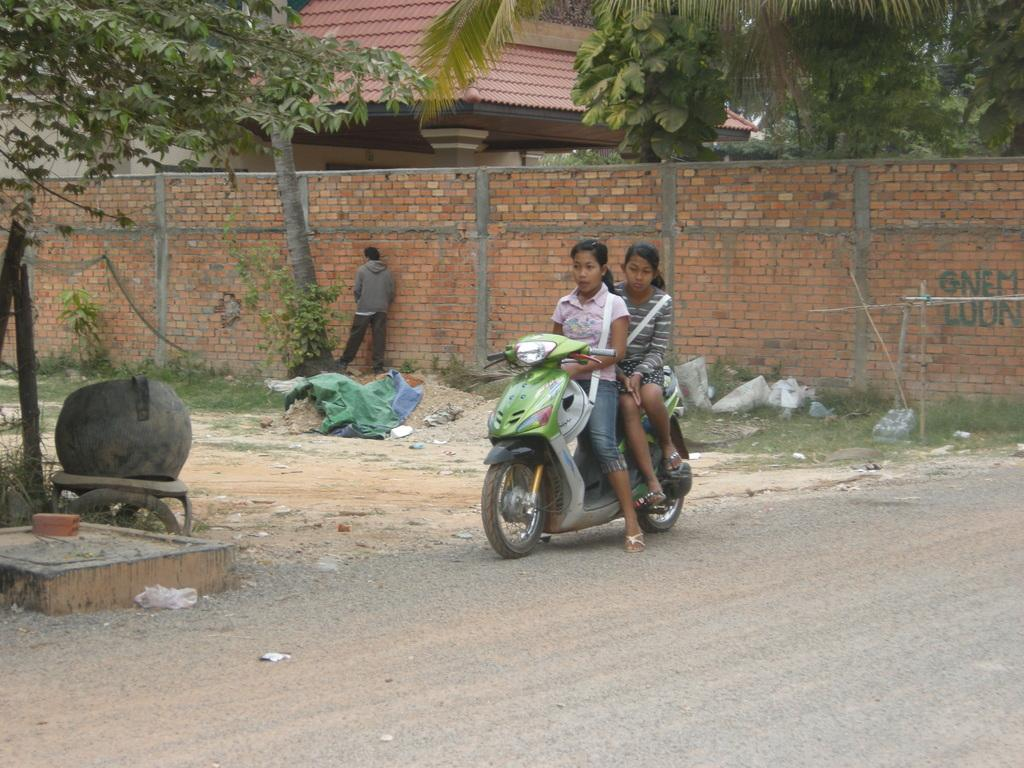What are the two girls doing in the image? The two girls are on a motorcycle in the image. Who else is present in the image? There is a man standing in the image. What type of natural environment can be seen in the image? There are trees visible in the image. What type of structure is present in the image? There is a brick wall and a house in the image. What type of game is being played by the squirrel in the image? There is no squirrel present in the image, so no game can be observed. What color is the kite flying in the image? There is no kite present in the image, so its color cannot be determined. 